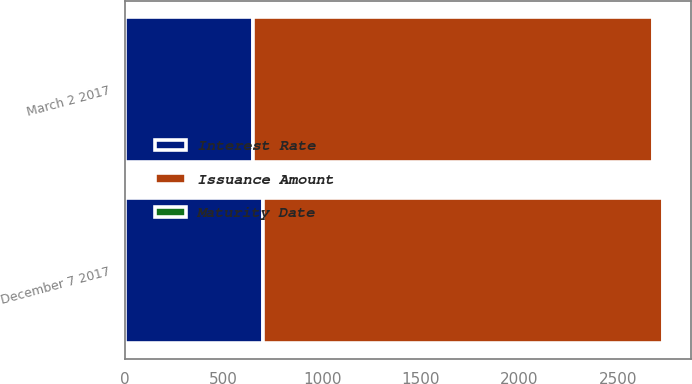Convert chart to OTSL. <chart><loc_0><loc_0><loc_500><loc_500><stacked_bar_chart><ecel><fcel>March 2 2017<fcel>December 7 2017<nl><fcel>Interest Rate<fcel>650<fcel>700<nl><fcel>Issuance Amount<fcel>2027<fcel>2028<nl><fcel>Maturity Date<fcel>3.2<fcel>3.2<nl></chart> 